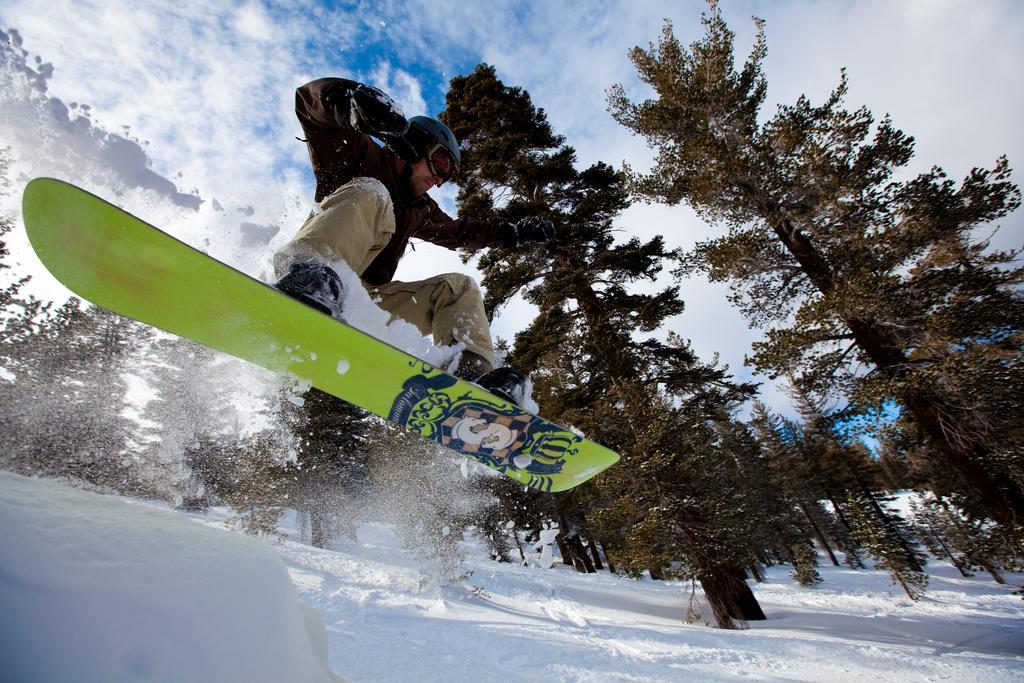Could you give a brief overview of what you see in this image? In the center of the image we can see one person surfing on the snow. And he is wearing a helmet. In the background, we can see the sky, clouds, trees and snow. 